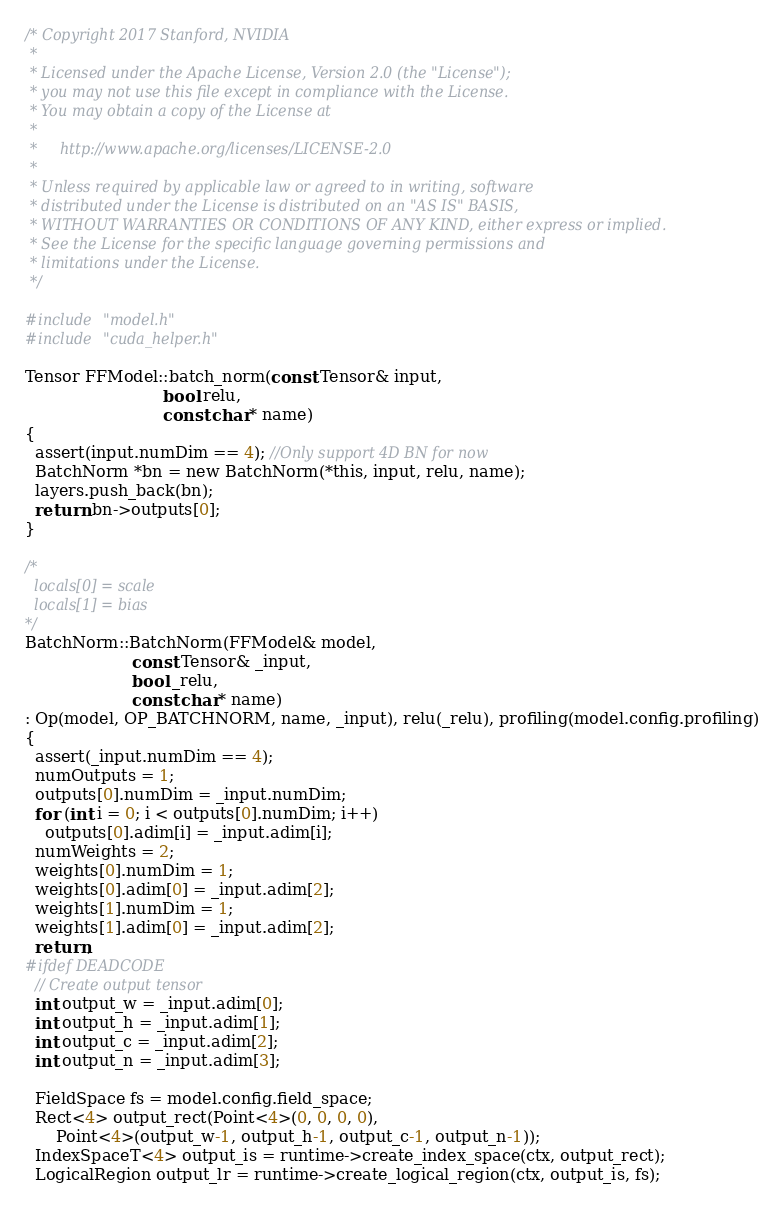Convert code to text. <code><loc_0><loc_0><loc_500><loc_500><_Cuda_>/* Copyright 2017 Stanford, NVIDIA
 *
 * Licensed under the Apache License, Version 2.0 (the "License");
 * you may not use this file except in compliance with the License.
 * You may obtain a copy of the License at
 *
 *     http://www.apache.org/licenses/LICENSE-2.0
 *
 * Unless required by applicable law or agreed to in writing, software
 * distributed under the License is distributed on an "AS IS" BASIS,
 * WITHOUT WARRANTIES OR CONDITIONS OF ANY KIND, either express or implied.
 * See the License for the specific language governing permissions and
 * limitations under the License.
 */

#include "model.h"
#include "cuda_helper.h"

Tensor FFModel::batch_norm(const Tensor& input,
                           bool relu,
                           const char* name)
{
  assert(input.numDim == 4); //Only support 4D BN for now
  BatchNorm *bn = new BatchNorm(*this, input, relu, name);
  layers.push_back(bn);
  return bn->outputs[0];
}

/*
  locals[0] = scale
  locals[1] = bias
*/
BatchNorm::BatchNorm(FFModel& model,
                     const Tensor& _input,
                     bool _relu,
                     const char* name)
: Op(model, OP_BATCHNORM, name, _input), relu(_relu), profiling(model.config.profiling)
{
  assert(_input.numDim == 4);
  numOutputs = 1;
  outputs[0].numDim = _input.numDim;
  for (int i = 0; i < outputs[0].numDim; i++)
    outputs[0].adim[i] = _input.adim[i];
  numWeights = 2;
  weights[0].numDim = 1;
  weights[0].adim[0] = _input.adim[2];
  weights[1].numDim = 1;
  weights[1].adim[0] = _input.adim[2];
  return;
#ifdef DEADCODE
  // Create output tensor
  int output_w = _input.adim[0];
  int output_h = _input.adim[1];
  int output_c = _input.adim[2];
  int output_n = _input.adim[3];

  FieldSpace fs = model.config.field_space;
  Rect<4> output_rect(Point<4>(0, 0, 0, 0),
      Point<4>(output_w-1, output_h-1, output_c-1, output_n-1));
  IndexSpaceT<4> output_is = runtime->create_index_space(ctx, output_rect);
  LogicalRegion output_lr = runtime->create_logical_region(ctx, output_is, fs);</code> 